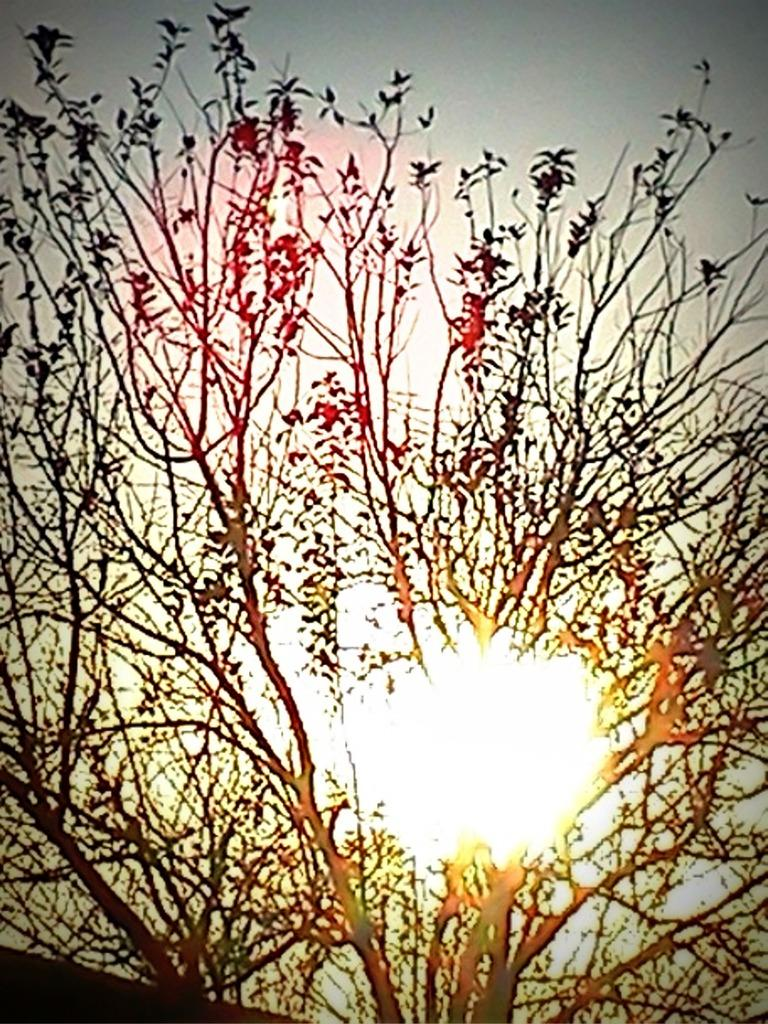What type of vegetation is in the foreground of the image? There are trees in the foreground of the image. What is visible at the top of the image? The sky is visible at the top of the image. Can the sun be seen in the sky? Yes, the sun is observable in the sky. What type of owl can be seen walking down the street in the image? There is no owl or street present in the image; it features trees and a sky with the sun visible. How is the owl being transported in the image? There is no owl or transportation method present in the image. 